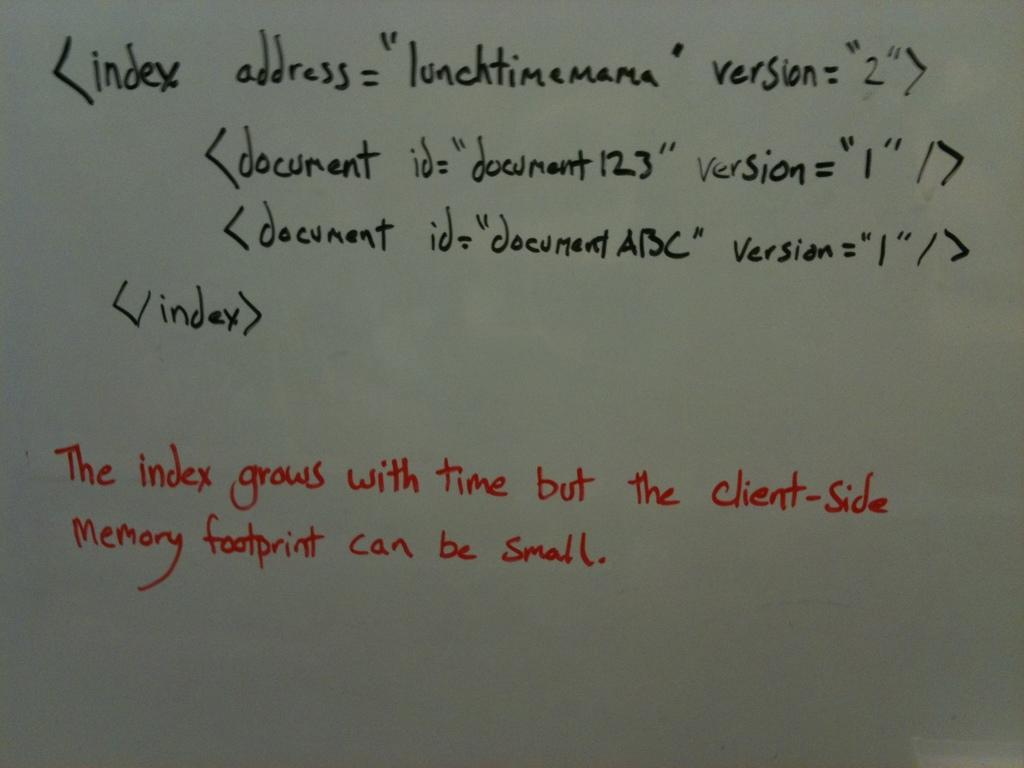Provide a one-sentence caption for the provided image. A white board has a complex code that says the index grows with time. 